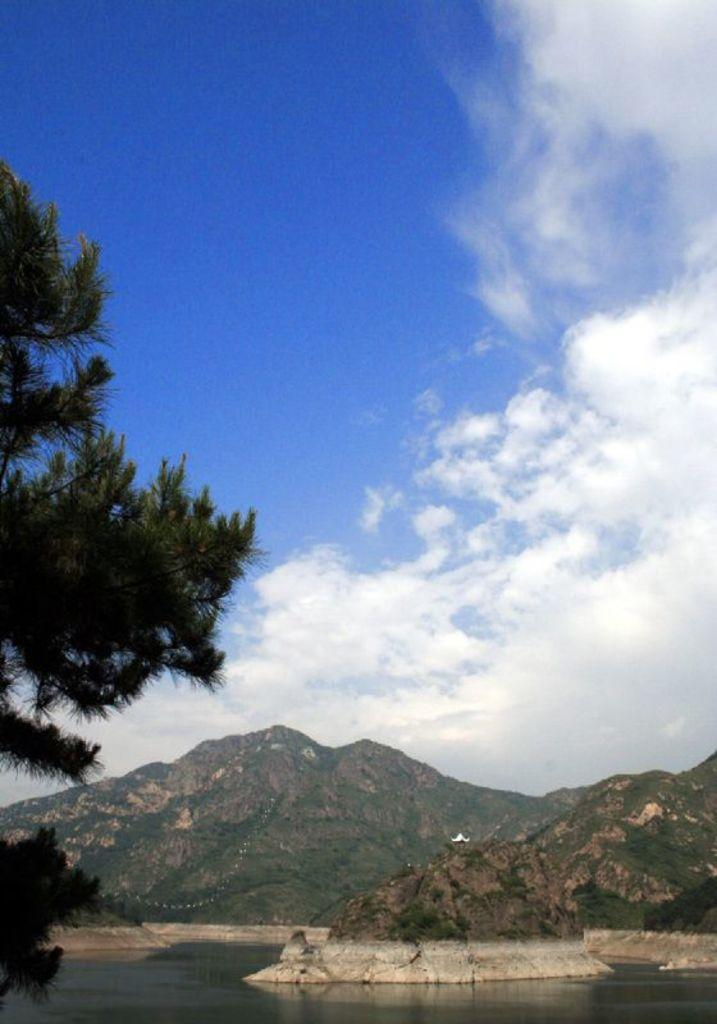What is visible in the front of the image? There is water in the front of the image. What can be seen in the background of the image? There are mountains in the background of the image. How would you describe the sky in the image? The sky is cloudy. Where is the tree located in the image? The tree is on the left side of the image. What type of boundary can be seen between the water and the mountains in the image? There is no specific boundary visible between the water and the mountains in the image. What treatment is being applied to the tree on the left side of the image? There is no treatment being applied to the tree in the image; it is simply a tree in the landscape. 